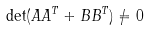Convert formula to latex. <formula><loc_0><loc_0><loc_500><loc_500>\det ( A A ^ { T } + B B ^ { T } ) \neq 0</formula> 